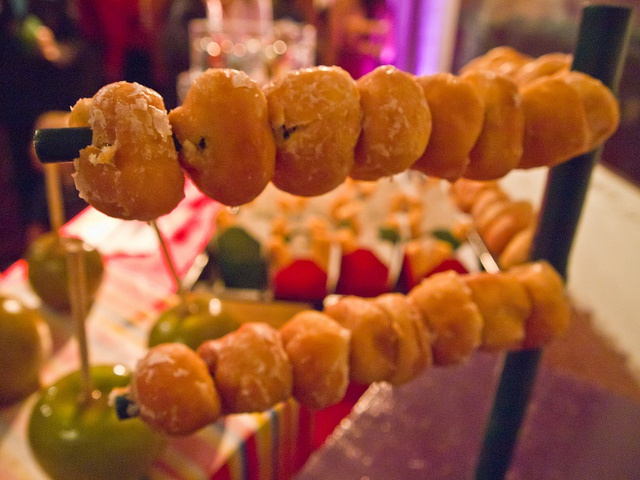Describe the objects in this image and their specific colors. I can see donut in black, brown, maroon, and tan tones, donut in black, brown, red, orange, and maroon tones, apple in black, olive, maroon, and tan tones, donut in black, brown, maroon, and red tones, and donut in black, brown, maroon, and orange tones in this image. 